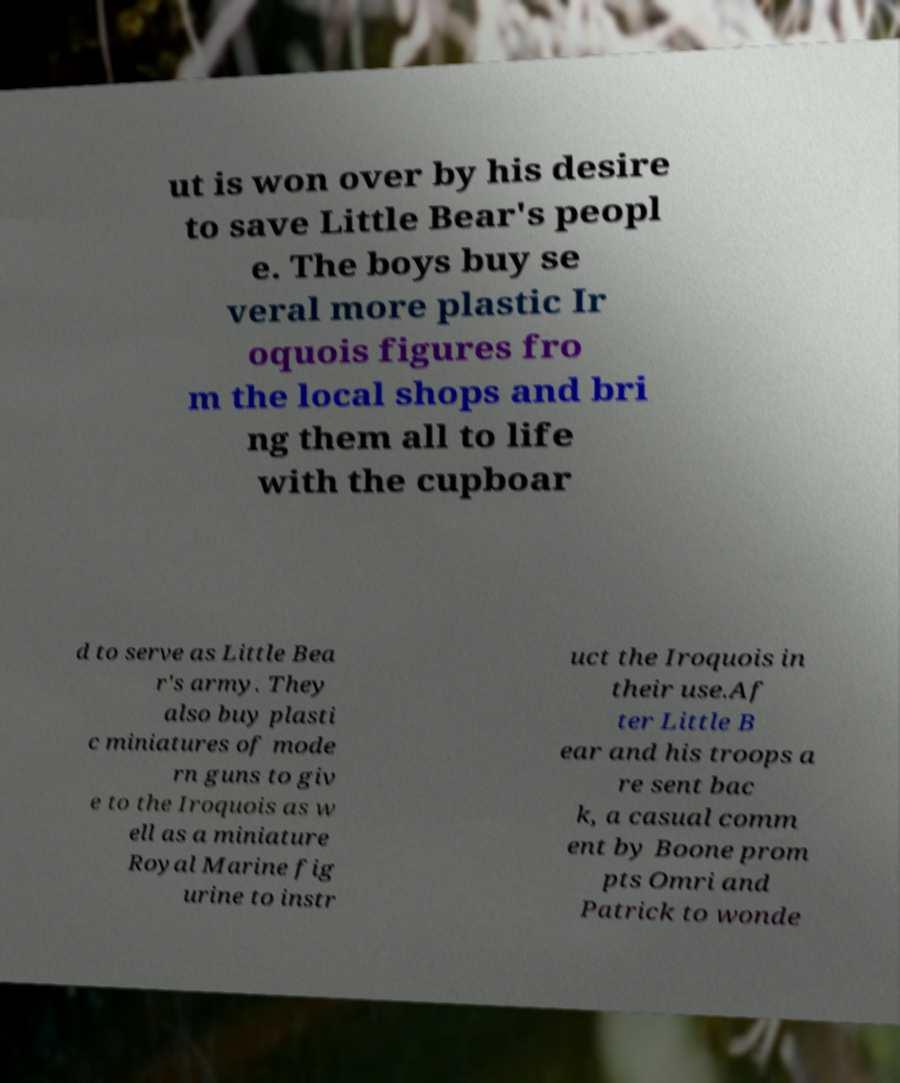Can you read and provide the text displayed in the image?This photo seems to have some interesting text. Can you extract and type it out for me? ut is won over by his desire to save Little Bear's peopl e. The boys buy se veral more plastic Ir oquois figures fro m the local shops and bri ng them all to life with the cupboar d to serve as Little Bea r's army. They also buy plasti c miniatures of mode rn guns to giv e to the Iroquois as w ell as a miniature Royal Marine fig urine to instr uct the Iroquois in their use.Af ter Little B ear and his troops a re sent bac k, a casual comm ent by Boone prom pts Omri and Patrick to wonde 